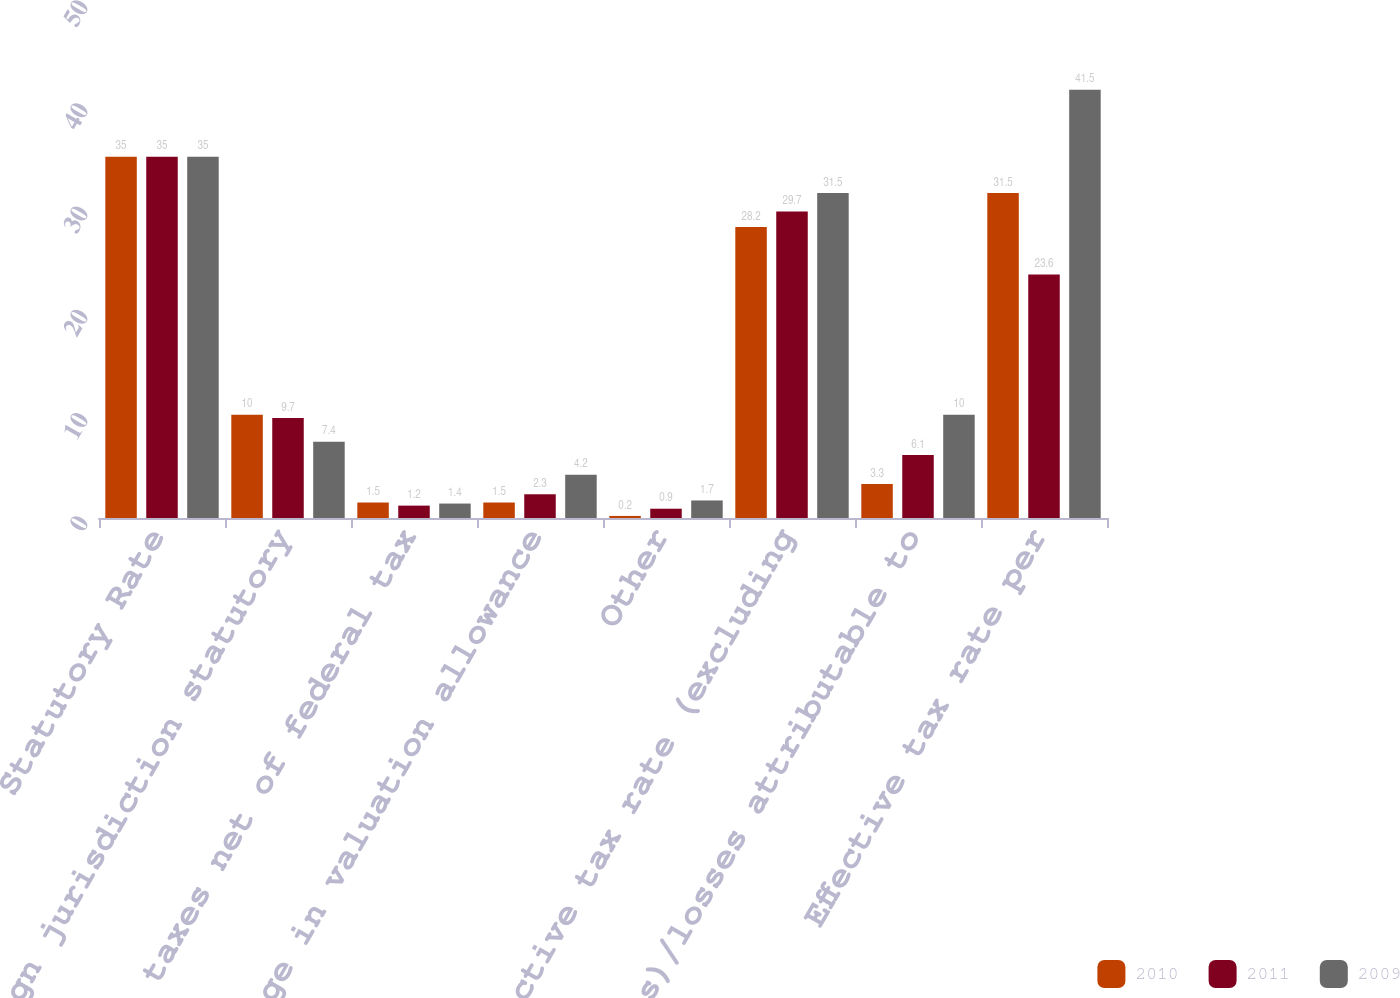Convert chart. <chart><loc_0><loc_0><loc_500><loc_500><stacked_bar_chart><ecel><fcel>Statutory Rate<fcel>Foreign jurisdiction statutory<fcel>State taxes net of federal tax<fcel>Change in valuation allowance<fcel>Other<fcel>Effective tax rate (excluding<fcel>(Gains)/losses attributable to<fcel>Effective tax rate per<nl><fcel>2010<fcel>35<fcel>10<fcel>1.5<fcel>1.5<fcel>0.2<fcel>28.2<fcel>3.3<fcel>31.5<nl><fcel>2011<fcel>35<fcel>9.7<fcel>1.2<fcel>2.3<fcel>0.9<fcel>29.7<fcel>6.1<fcel>23.6<nl><fcel>2009<fcel>35<fcel>7.4<fcel>1.4<fcel>4.2<fcel>1.7<fcel>31.5<fcel>10<fcel>41.5<nl></chart> 